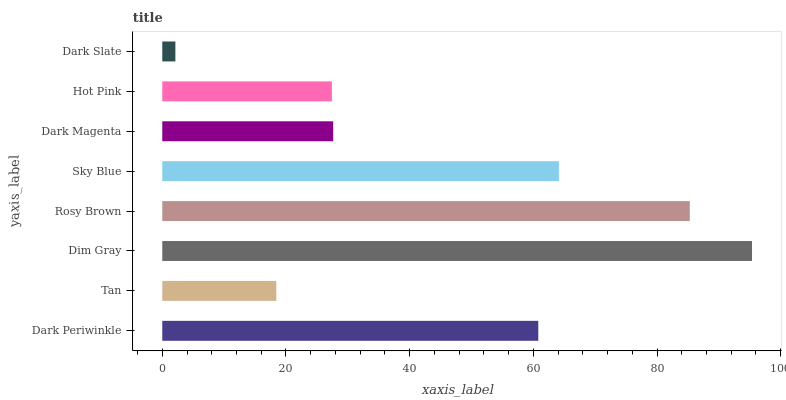Is Dark Slate the minimum?
Answer yes or no. Yes. Is Dim Gray the maximum?
Answer yes or no. Yes. Is Tan the minimum?
Answer yes or no. No. Is Tan the maximum?
Answer yes or no. No. Is Dark Periwinkle greater than Tan?
Answer yes or no. Yes. Is Tan less than Dark Periwinkle?
Answer yes or no. Yes. Is Tan greater than Dark Periwinkle?
Answer yes or no. No. Is Dark Periwinkle less than Tan?
Answer yes or no. No. Is Dark Periwinkle the high median?
Answer yes or no. Yes. Is Dark Magenta the low median?
Answer yes or no. Yes. Is Hot Pink the high median?
Answer yes or no. No. Is Dim Gray the low median?
Answer yes or no. No. 